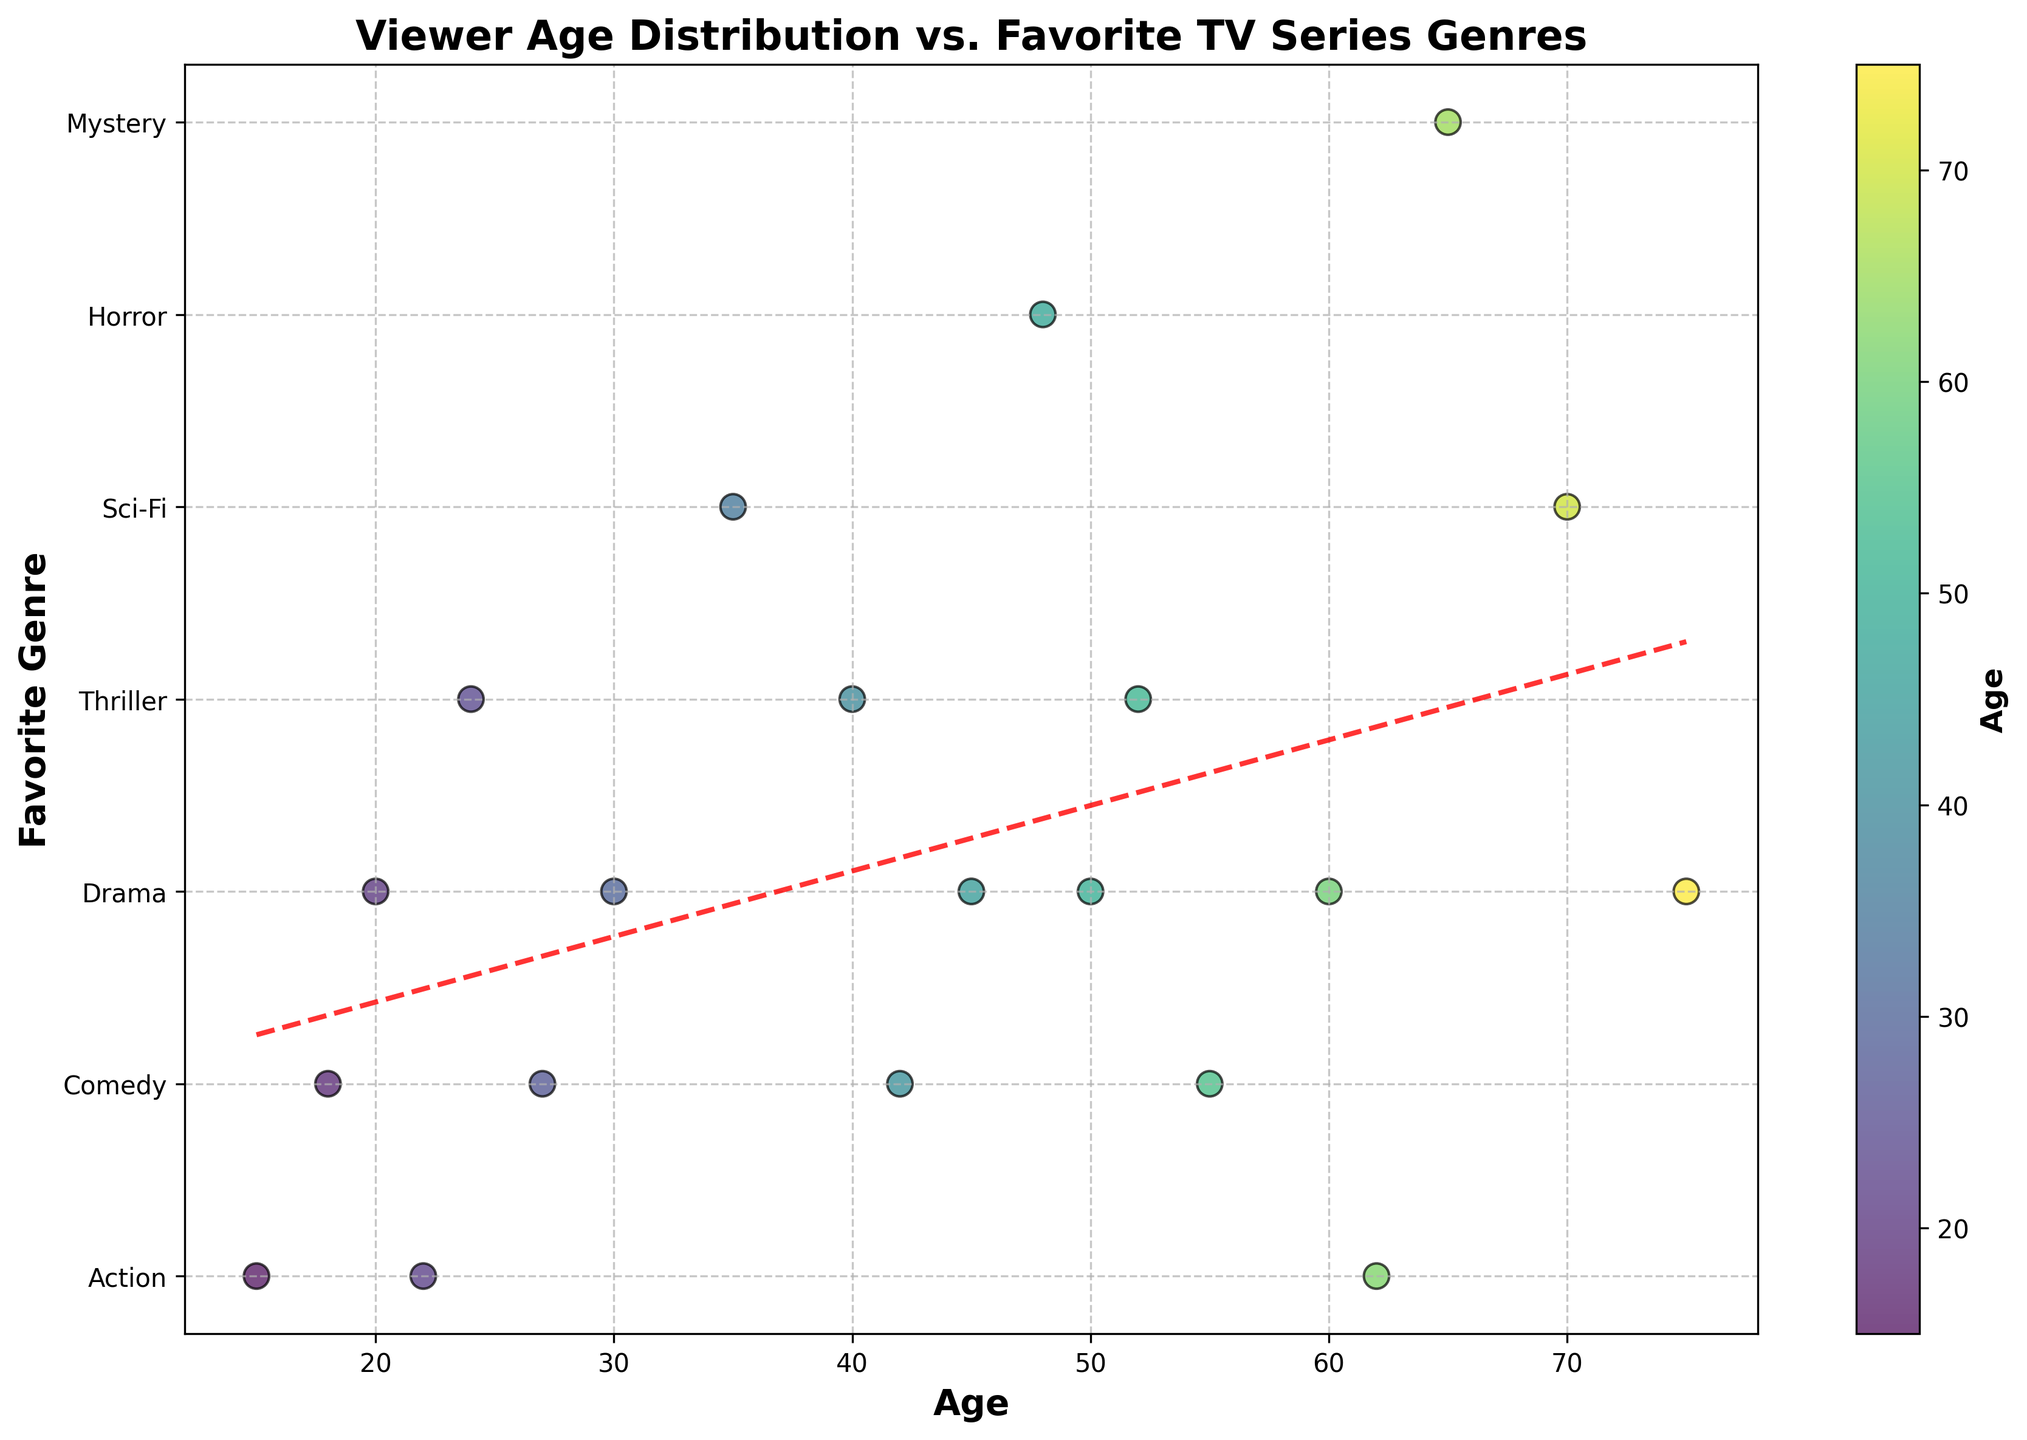What is the title of the figure? The title of the figure is usually displayed at the top of the chart. Here, it is written in bold and can be read directly from the figure.
Answer: Viewer Age Distribution vs. Favorite TV Series Genres What data does the y-axis represent? The y-axis is labeled, and here we can see that it indicates the 'Favorite Genre' of viewers.
Answer: Favorite Genre Which genre appears at the highest average age? By looking at the placement of the trend line in relation to the genres on the y-axis, we can infer that the 'Drama' genre, which appears near the older age range, corresponds to the highest average age.
Answer: Drama Is there a correlation between age and preference for the 'Comedy' genre? To answer this, we look at where 'Comedy' genre data points are scattered. We can see these points are widely distributed across different ages, indicating that age isn't strongly correlated with a preference for the 'Comedy' genre.
Answer: No Which genre is most preferred by viewers aged 60 and above? By examining the data points at age 60 and above, we observe that they correspond primarily to the 'Drama' genre.
Answer: Drama How many genres are visualized in the plot? The unique genre values indicated on the y-axis and their respective labels give us the total count of distinct genres.
Answer: 7 Among viewers in their 20s, which genre is the least preferred? Checking the distribution of data points for viewers in their 20s, we see that 'Sci-Fi' and 'Horror' are absent in this age group, so both are the least preferred genres.
Answer: Sci-Fi and Horror Is there a trend indicating that certain genres are more popular among younger viewers? The trend line helps in identifying general patterns. The trend line's slope can indicate that younger viewers tend to prefer 'Action' and 'Comedy' genres, while older genres prefer 'Drama'.
Answer: Yes 